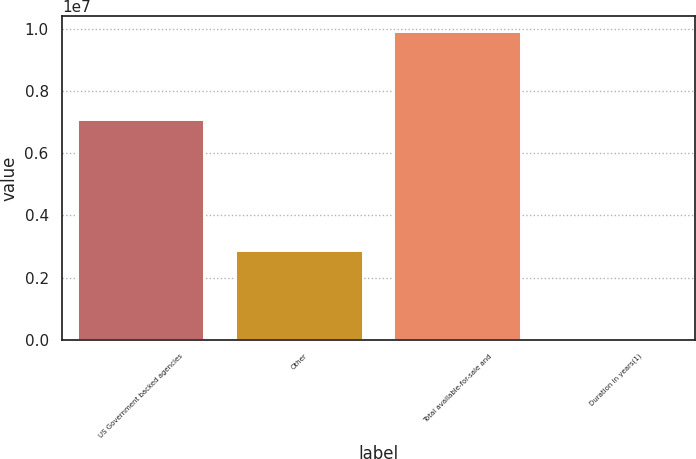Convert chart to OTSL. <chart><loc_0><loc_0><loc_500><loc_500><bar_chart><fcel>US Government backed agencies<fcel>Other<fcel>Total available-for-sale and<fcel>Duration in years(1)<nl><fcel>7.04803e+06<fcel>2.84722e+06<fcel>9.89524e+06<fcel>3<nl></chart> 